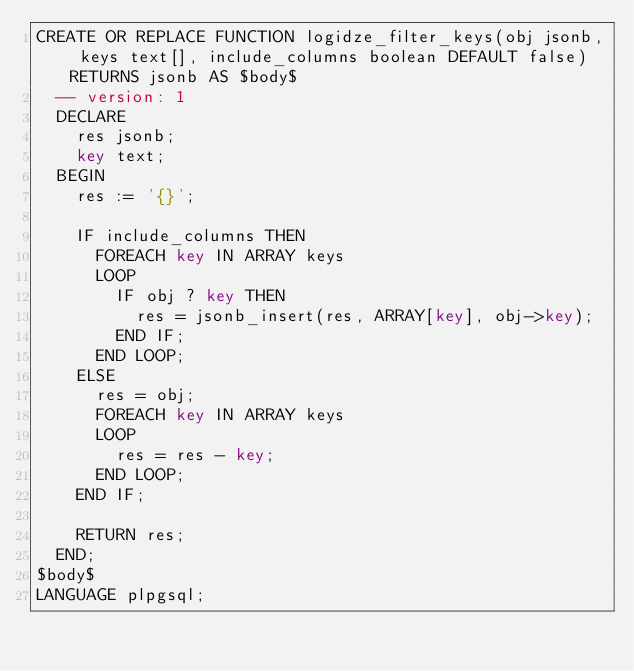Convert code to text. <code><loc_0><loc_0><loc_500><loc_500><_SQL_>CREATE OR REPLACE FUNCTION logidze_filter_keys(obj jsonb, keys text[], include_columns boolean DEFAULT false) RETURNS jsonb AS $body$
  -- version: 1
  DECLARE
    res jsonb;
    key text;
  BEGIN
    res := '{}';

    IF include_columns THEN
      FOREACH key IN ARRAY keys
      LOOP
        IF obj ? key THEN
          res = jsonb_insert(res, ARRAY[key], obj->key);
        END IF;
      END LOOP;
    ELSE
      res = obj;
      FOREACH key IN ARRAY keys
      LOOP
        res = res - key;
      END LOOP;
    END IF;

    RETURN res;
  END;
$body$
LANGUAGE plpgsql;
</code> 